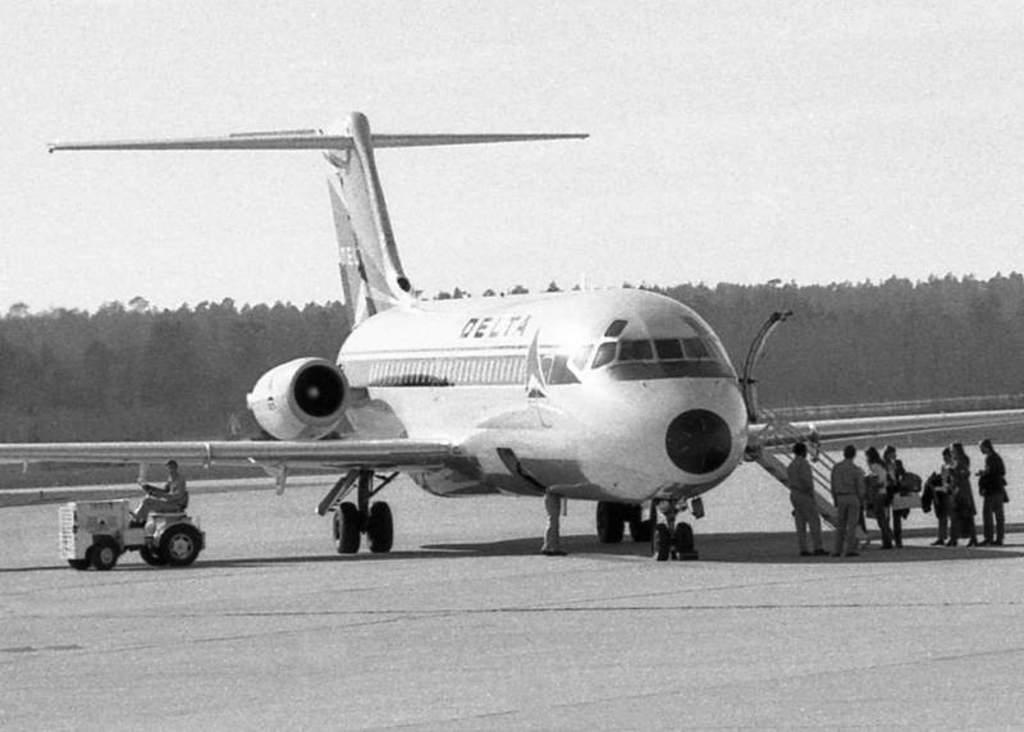What is the main subject of the image? The main subject of the image is an airplane. What are the people near the airplane doing? The people standing near the airplane are likely waiting to board or have just disembarked. What is the person in the image doing? There is a person driving a vehicle in the image. What can be seen in the background of the image? Trees and the sky are visible in the background of the image. What type of stitch is being used to sew the bird's wing in the image? There is no bird or stitching present in the image; it features an airplane and people near it. How many rocks can be seen in the image? There are no rocks visible in the image. 